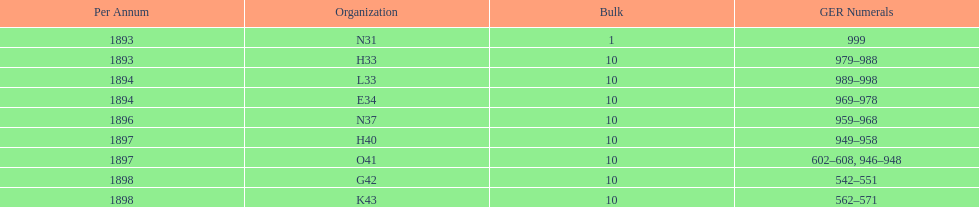What is the order of the last year listed? K43. 